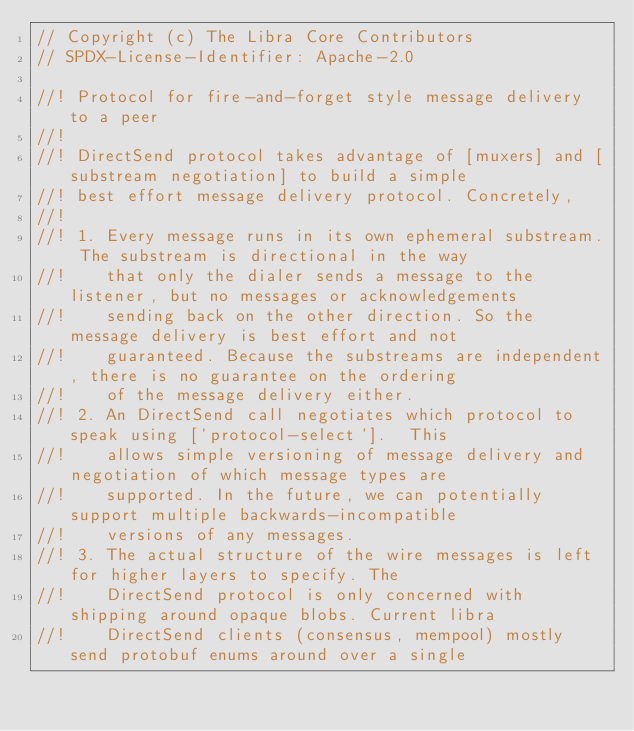Convert code to text. <code><loc_0><loc_0><loc_500><loc_500><_Rust_>// Copyright (c) The Libra Core Contributors
// SPDX-License-Identifier: Apache-2.0

//! Protocol for fire-and-forget style message delivery to a peer
//!
//! DirectSend protocol takes advantage of [muxers] and [substream negotiation] to build a simple
//! best effort message delivery protocol. Concretely,
//!
//! 1. Every message runs in its own ephemeral substream. The substream is directional in the way
//!    that only the dialer sends a message to the listener, but no messages or acknowledgements
//!    sending back on the other direction. So the message delivery is best effort and not
//!    guaranteed. Because the substreams are independent, there is no guarantee on the ordering
//!    of the message delivery either.
//! 2. An DirectSend call negotiates which protocol to speak using [`protocol-select`].  This
//!    allows simple versioning of message delivery and negotiation of which message types are
//!    supported. In the future, we can potentially support multiple backwards-incompatible
//!    versions of any messages.
//! 3. The actual structure of the wire messages is left for higher layers to specify. The
//!    DirectSend protocol is only concerned with shipping around opaque blobs. Current libra
//!    DirectSend clients (consensus, mempool) mostly send protobuf enums around over a single</code> 